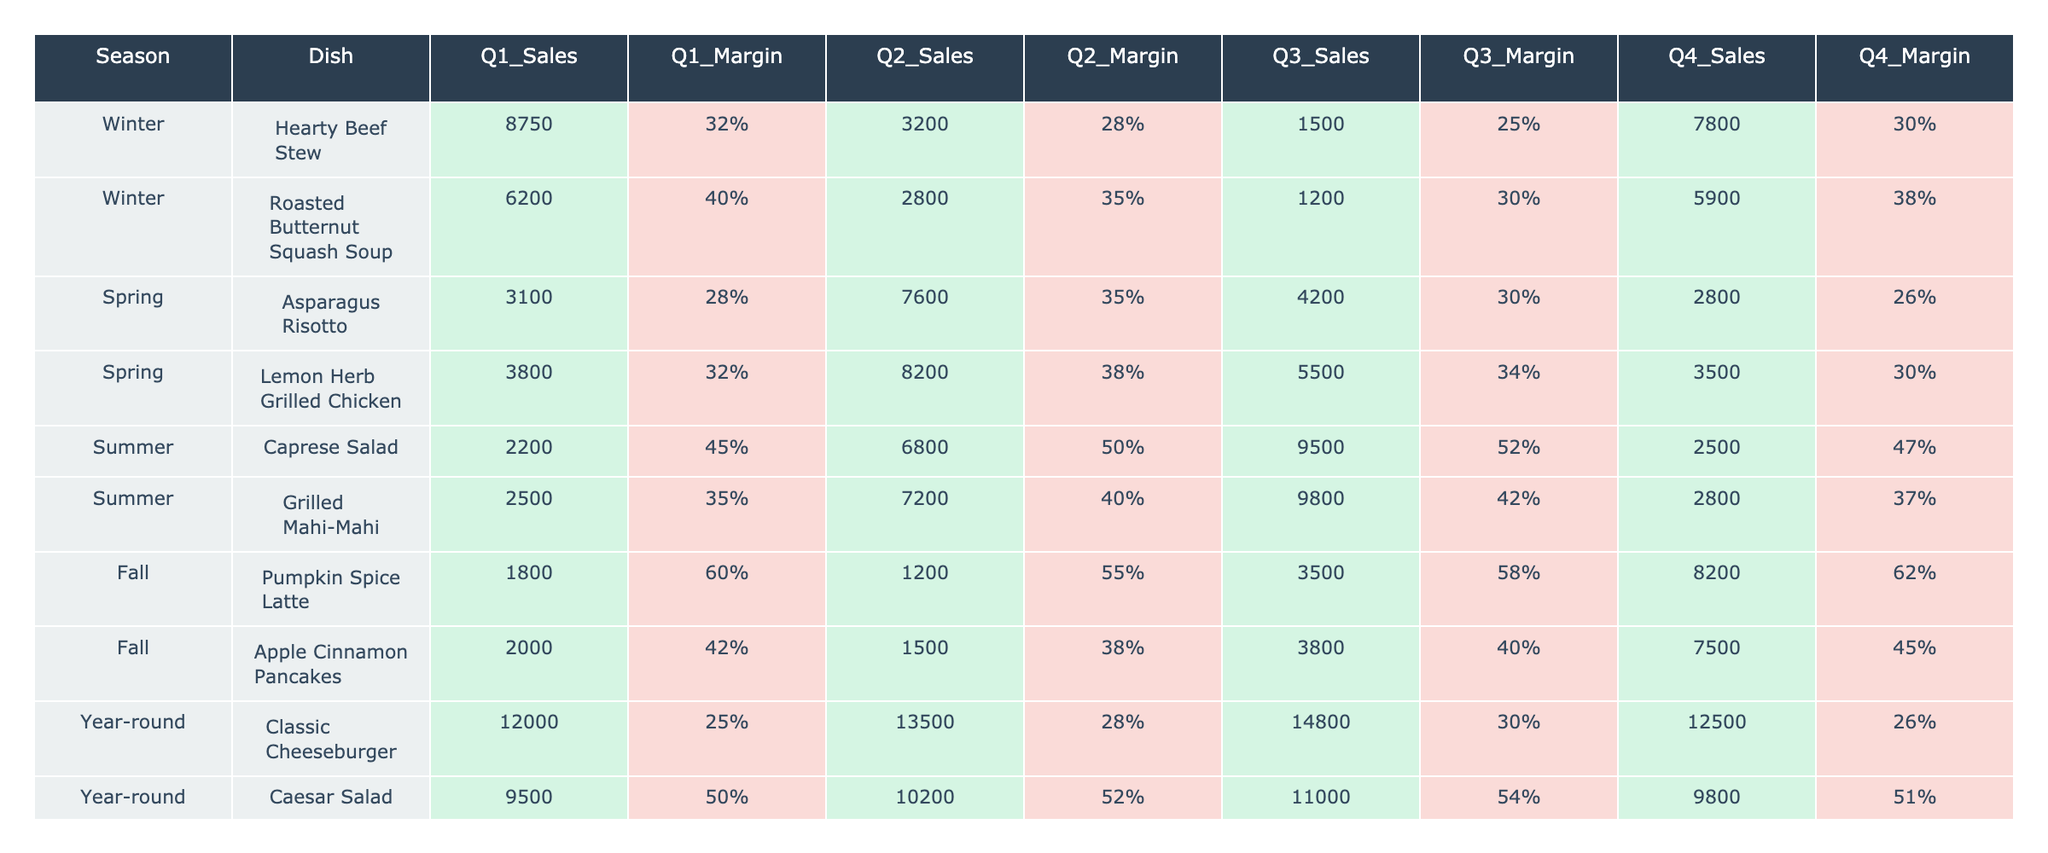What is the total sales for the Hearty Beef Stew in Q1? By referring to the table, the sales for Hearty Beef Stew in Q1 is listed as 8750. Therefore, the total sales amount is directly taken from that entry.
Answer: 8750 Which dish had the highest profit margin in Q3? By checking the Q3 profit margins in the table, the profit margin for each dish is compared. The dish with the highest margin is the Caprese Salad, which has a profit margin of 52%.
Answer: Caprese Salad What is the average profit margin of all dishes in Q2? The profit margins for Q2 are: 28%, 35%, 38%, 50%, 40%, 55%, 38%, 52%. Adding them gives 28 + 35 + 38 + 50 + 40 + 55 + 38 + 52 = 336. There are 8 dishes, so 336 divided by 8 equals 42%.
Answer: 42% Did the sales for Lemon Herb Grilled Chicken decrease from Q1 to Q4? The sales figures in the table show that Lemon Herb Grilled Chicken had sales of 3800 in Q1, while in Q4, the sales were 3500. Since 3500 is less than 3800, the sales did indeed decrease.
Answer: Yes What is the difference in sales between the Apple Cinnamon Pancakes in Q1 and Q3? The sales for Apple Cinnamon Pancakes are 2000 in Q1 and 3800 in Q3. To find the difference, subtract Q1 from Q3: 3800 - 2000 = 1800.
Answer: 1800 Which dish had the lowest total sales across all quarters? The total sales for each dish are calculated by summing all four quarters. For Apple Cinnamon Pancakes: 2000 + 1500 + 3800 + 7500 = 15300. By performing similar calculations for all dishes, it's determined that the Hearty Beef Stew has the lowest total sales of 22650.
Answer: Hearty Beef Stew Is there any dish that has a profit margin of over 60% in Q4? By examining the profit margins in Q4, only the Pumpkin Spice Latte has a profit margin of 62%, which is over 60%. Therefore, there is indeed one dish that meets this criterion.
Answer: Yes What was the total sales for all Spring dishes in Q1? The sales for Spring dishes in Q1 are Asparagus Risotto (3100) and Lemon Herb Grilled Chicken (3800). Adding these gives 3100 + 3800 = 6900.
Answer: 6900 Which quarter had the highest total sales for the Roasted Butternut Squash Soup? The sales figures from the table indicate that Q1 sales were 6200, Q2 sales were 2800, Q3 sales were 1200, and Q4 sales were 5900. The highest of these is 6200 in Q1.
Answer: Q1 Which season had the highest average profit margin across all dishes? The average profit margins per season are calculated by summing the margins and dividing by the number of dishes in each season. Winter: (32 + 40)/2 = 36%, Spring: (28 + 32)/2 = 30%, Summer: (45 + 35)/2 = 40%. Winter has the highest average at 36%.
Answer: Winter 